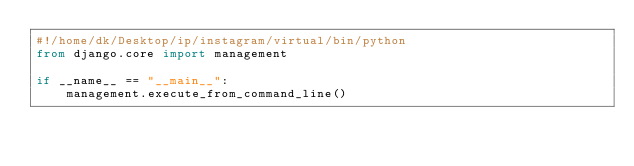Convert code to text. <code><loc_0><loc_0><loc_500><loc_500><_Python_>#!/home/dk/Desktop/ip/instagram/virtual/bin/python
from django.core import management

if __name__ == "__main__":
    management.execute_from_command_line()
</code> 